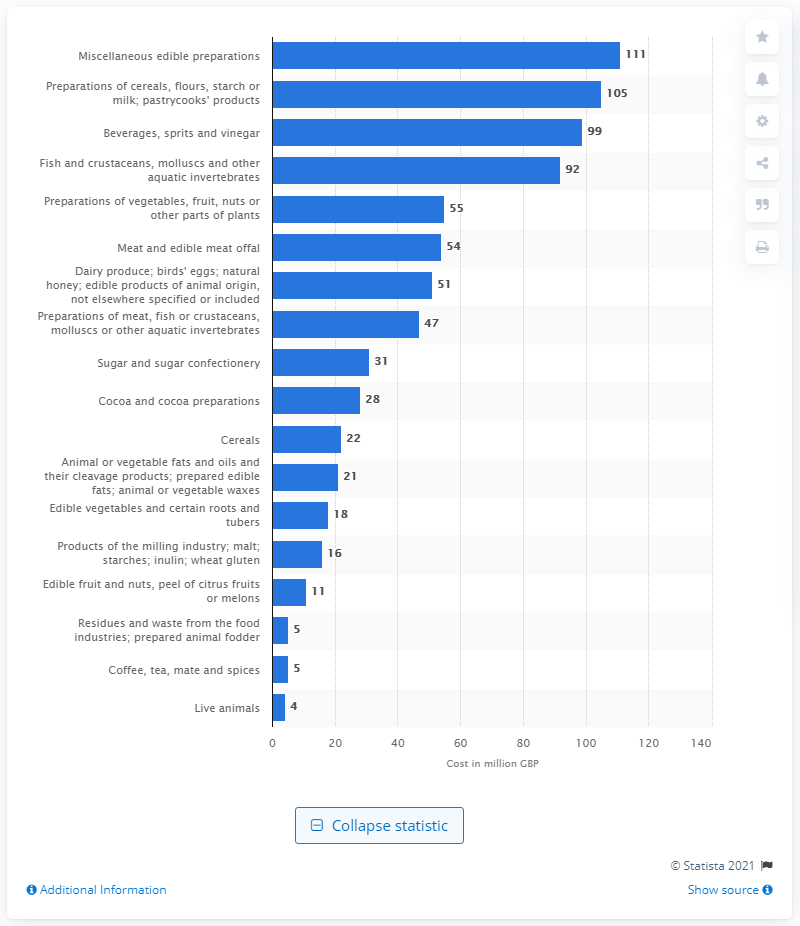Give some essential details in this illustration. It is estimated that the trade of edible preparations could cost 111 pounds without a free-trade deal. The cost of cereals, flours, starch, and milk could potentially increase by 105 pounds without a free trade deal. 